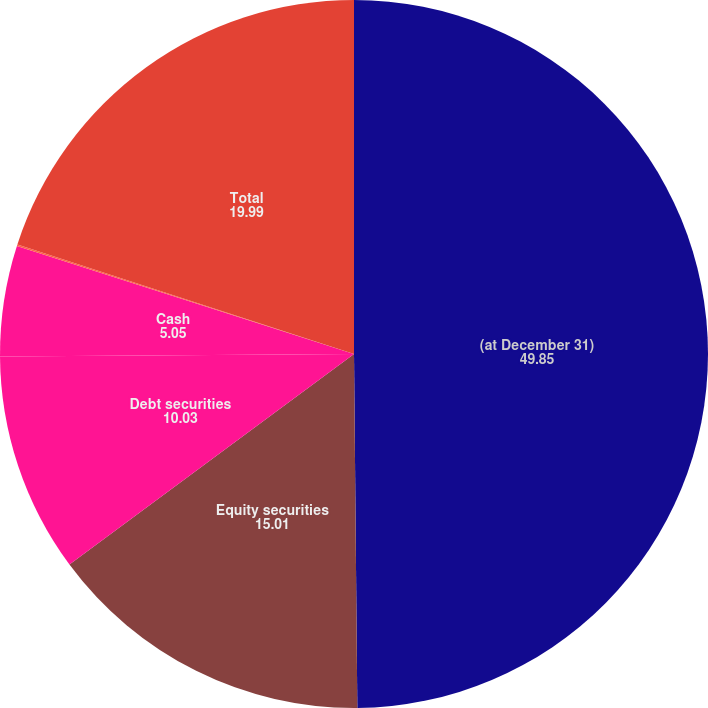<chart> <loc_0><loc_0><loc_500><loc_500><pie_chart><fcel>(at December 31)<fcel>Equity securities<fcel>Debt securities<fcel>Cash<fcel>Other<fcel>Total<nl><fcel>49.85%<fcel>15.01%<fcel>10.03%<fcel>5.05%<fcel>0.07%<fcel>19.99%<nl></chart> 